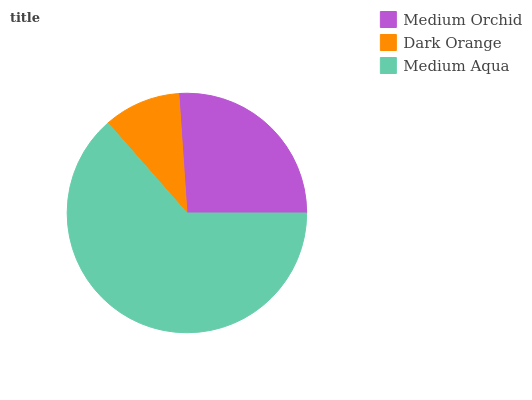Is Dark Orange the minimum?
Answer yes or no. Yes. Is Medium Aqua the maximum?
Answer yes or no. Yes. Is Medium Aqua the minimum?
Answer yes or no. No. Is Dark Orange the maximum?
Answer yes or no. No. Is Medium Aqua greater than Dark Orange?
Answer yes or no. Yes. Is Dark Orange less than Medium Aqua?
Answer yes or no. Yes. Is Dark Orange greater than Medium Aqua?
Answer yes or no. No. Is Medium Aqua less than Dark Orange?
Answer yes or no. No. Is Medium Orchid the high median?
Answer yes or no. Yes. Is Medium Orchid the low median?
Answer yes or no. Yes. Is Medium Aqua the high median?
Answer yes or no. No. Is Medium Aqua the low median?
Answer yes or no. No. 